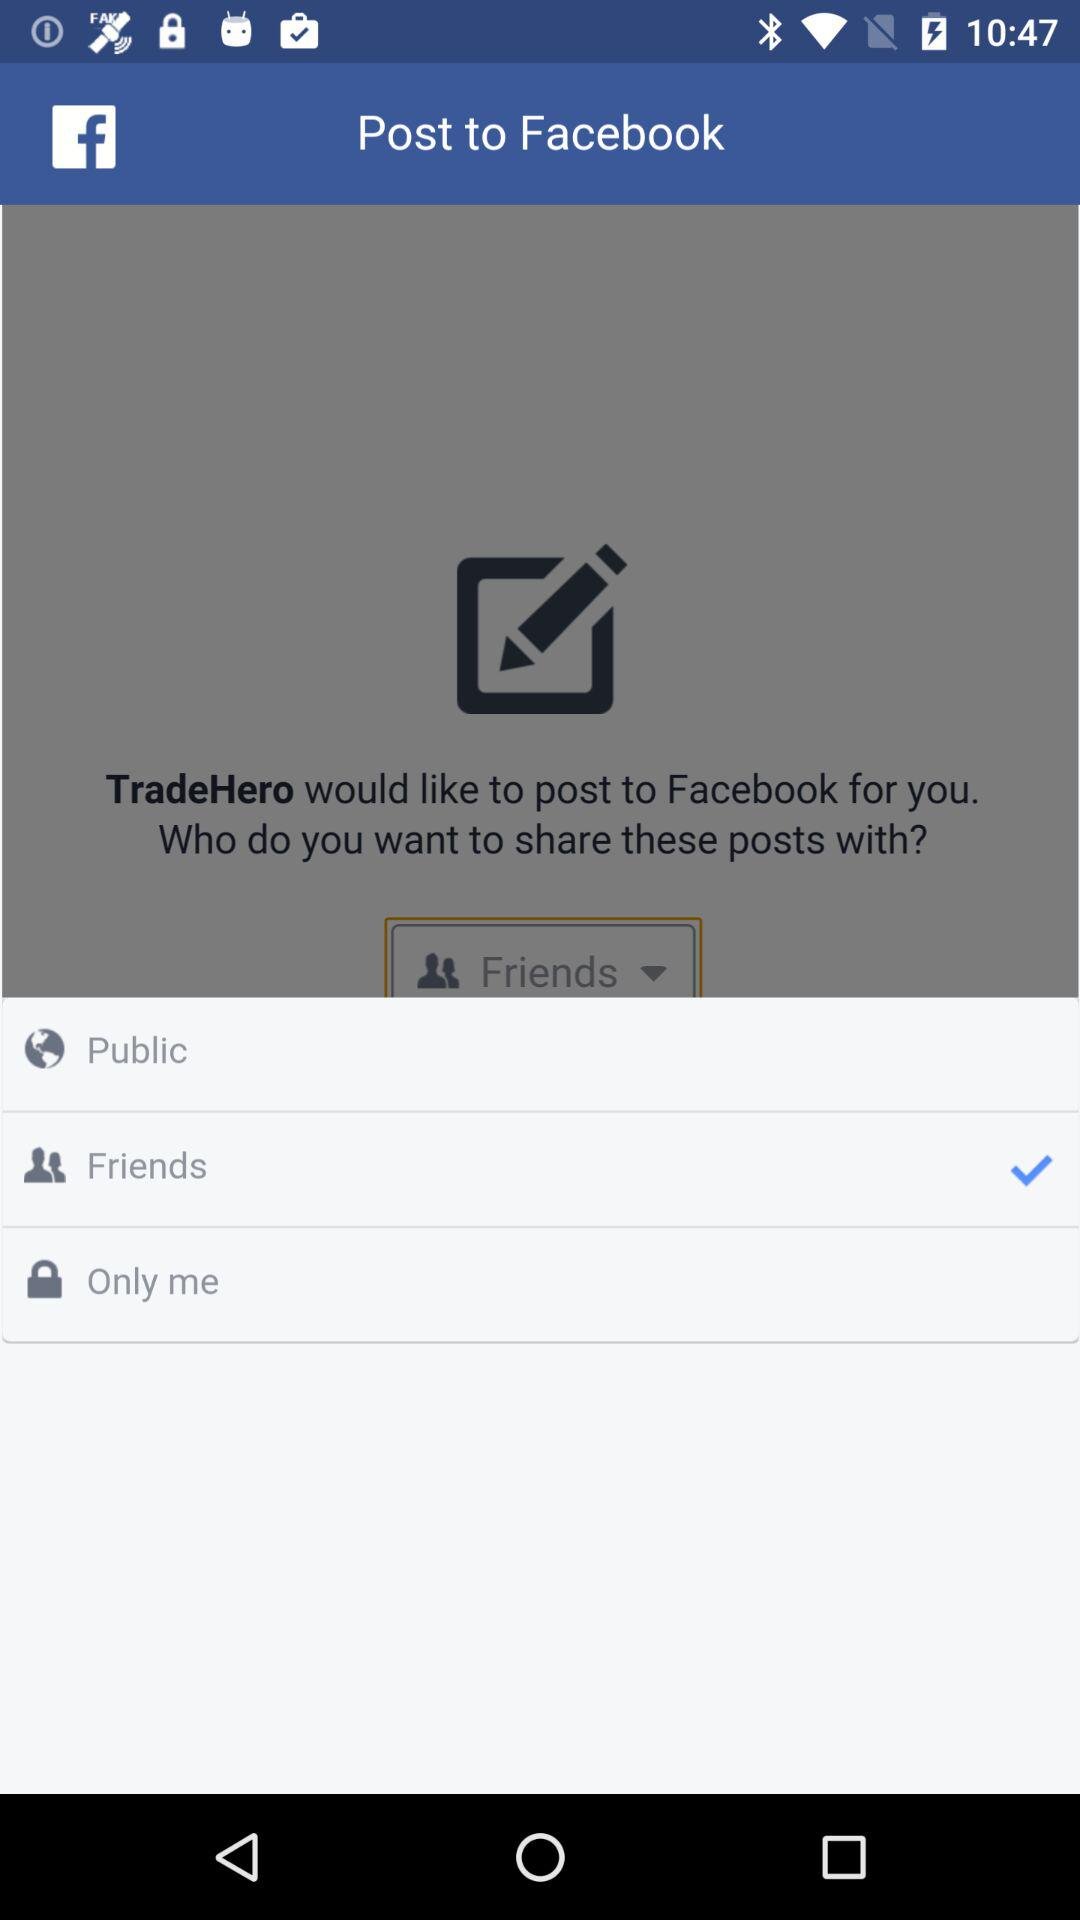Which option is selected for the Facebook post? The selected option is "Friends". 